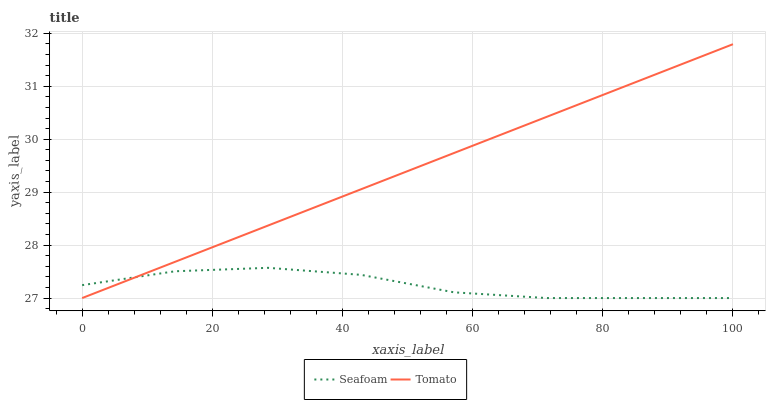Does Seafoam have the maximum area under the curve?
Answer yes or no. No. Is Seafoam the smoothest?
Answer yes or no. No. Does Seafoam have the highest value?
Answer yes or no. No. 